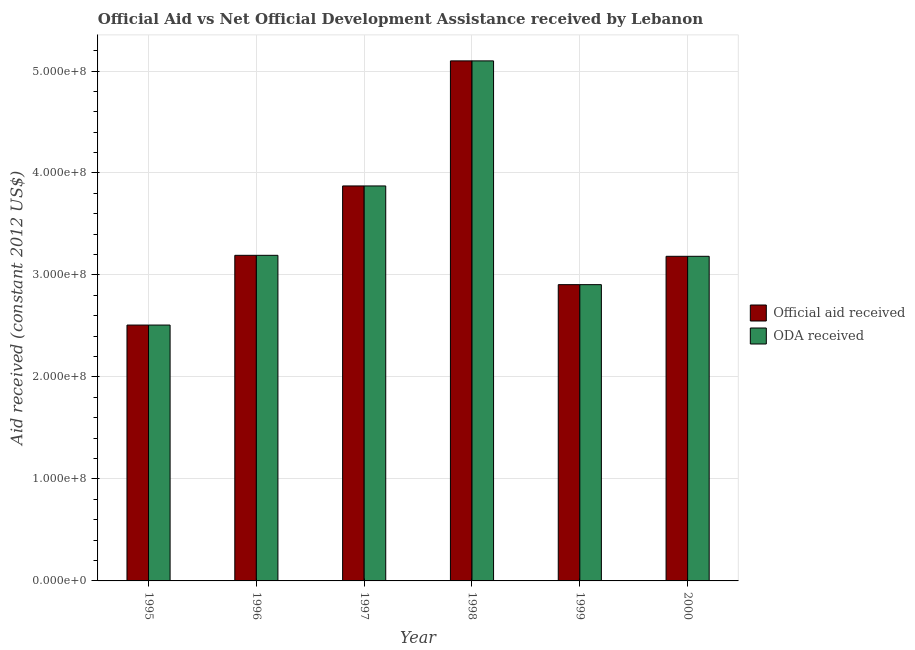How many different coloured bars are there?
Give a very brief answer. 2. Are the number of bars per tick equal to the number of legend labels?
Ensure brevity in your answer.  Yes. Are the number of bars on each tick of the X-axis equal?
Your answer should be compact. Yes. What is the oda received in 1999?
Your answer should be compact. 2.91e+08. Across all years, what is the maximum official aid received?
Your answer should be compact. 5.10e+08. Across all years, what is the minimum oda received?
Ensure brevity in your answer.  2.51e+08. In which year was the oda received minimum?
Provide a succinct answer. 1995. What is the total oda received in the graph?
Keep it short and to the point. 2.08e+09. What is the difference between the official aid received in 1995 and that in 1997?
Make the answer very short. -1.36e+08. What is the difference between the official aid received in 1996 and the oda received in 1997?
Offer a very short reply. -6.80e+07. What is the average oda received per year?
Make the answer very short. 3.46e+08. What is the ratio of the oda received in 1999 to that in 2000?
Make the answer very short. 0.91. What is the difference between the highest and the second highest official aid received?
Give a very brief answer. 1.23e+08. What is the difference between the highest and the lowest oda received?
Offer a very short reply. 2.59e+08. What does the 1st bar from the left in 1999 represents?
Provide a short and direct response. Official aid received. What does the 1st bar from the right in 2000 represents?
Your answer should be compact. ODA received. How many bars are there?
Keep it short and to the point. 12. What is the difference between two consecutive major ticks on the Y-axis?
Your response must be concise. 1.00e+08. Are the values on the major ticks of Y-axis written in scientific E-notation?
Ensure brevity in your answer.  Yes. Does the graph contain grids?
Provide a short and direct response. Yes. How are the legend labels stacked?
Your answer should be very brief. Vertical. What is the title of the graph?
Your answer should be compact. Official Aid vs Net Official Development Assistance received by Lebanon . What is the label or title of the X-axis?
Keep it short and to the point. Year. What is the label or title of the Y-axis?
Keep it short and to the point. Aid received (constant 2012 US$). What is the Aid received (constant 2012 US$) in Official aid received in 1995?
Provide a short and direct response. 2.51e+08. What is the Aid received (constant 2012 US$) of ODA received in 1995?
Your answer should be very brief. 2.51e+08. What is the Aid received (constant 2012 US$) in Official aid received in 1996?
Give a very brief answer. 3.19e+08. What is the Aid received (constant 2012 US$) of ODA received in 1996?
Keep it short and to the point. 3.19e+08. What is the Aid received (constant 2012 US$) of Official aid received in 1997?
Keep it short and to the point. 3.87e+08. What is the Aid received (constant 2012 US$) of ODA received in 1997?
Give a very brief answer. 3.87e+08. What is the Aid received (constant 2012 US$) of Official aid received in 1998?
Provide a succinct answer. 5.10e+08. What is the Aid received (constant 2012 US$) in ODA received in 1998?
Provide a short and direct response. 5.10e+08. What is the Aid received (constant 2012 US$) of Official aid received in 1999?
Your answer should be compact. 2.91e+08. What is the Aid received (constant 2012 US$) in ODA received in 1999?
Offer a very short reply. 2.91e+08. What is the Aid received (constant 2012 US$) in Official aid received in 2000?
Provide a succinct answer. 3.18e+08. What is the Aid received (constant 2012 US$) of ODA received in 2000?
Your answer should be very brief. 3.18e+08. Across all years, what is the maximum Aid received (constant 2012 US$) in Official aid received?
Provide a succinct answer. 5.10e+08. Across all years, what is the maximum Aid received (constant 2012 US$) in ODA received?
Your response must be concise. 5.10e+08. Across all years, what is the minimum Aid received (constant 2012 US$) of Official aid received?
Provide a short and direct response. 2.51e+08. Across all years, what is the minimum Aid received (constant 2012 US$) in ODA received?
Your answer should be compact. 2.51e+08. What is the total Aid received (constant 2012 US$) of Official aid received in the graph?
Provide a short and direct response. 2.08e+09. What is the total Aid received (constant 2012 US$) in ODA received in the graph?
Your answer should be very brief. 2.08e+09. What is the difference between the Aid received (constant 2012 US$) in Official aid received in 1995 and that in 1996?
Provide a succinct answer. -6.84e+07. What is the difference between the Aid received (constant 2012 US$) in ODA received in 1995 and that in 1996?
Ensure brevity in your answer.  -6.84e+07. What is the difference between the Aid received (constant 2012 US$) in Official aid received in 1995 and that in 1997?
Offer a very short reply. -1.36e+08. What is the difference between the Aid received (constant 2012 US$) in ODA received in 1995 and that in 1997?
Your answer should be very brief. -1.36e+08. What is the difference between the Aid received (constant 2012 US$) in Official aid received in 1995 and that in 1998?
Provide a succinct answer. -2.59e+08. What is the difference between the Aid received (constant 2012 US$) of ODA received in 1995 and that in 1998?
Your answer should be compact. -2.59e+08. What is the difference between the Aid received (constant 2012 US$) of Official aid received in 1995 and that in 1999?
Your answer should be very brief. -3.96e+07. What is the difference between the Aid received (constant 2012 US$) in ODA received in 1995 and that in 1999?
Keep it short and to the point. -3.96e+07. What is the difference between the Aid received (constant 2012 US$) in Official aid received in 1995 and that in 2000?
Make the answer very short. -6.74e+07. What is the difference between the Aid received (constant 2012 US$) in ODA received in 1995 and that in 2000?
Your answer should be very brief. -6.74e+07. What is the difference between the Aid received (constant 2012 US$) in Official aid received in 1996 and that in 1997?
Give a very brief answer. -6.80e+07. What is the difference between the Aid received (constant 2012 US$) in ODA received in 1996 and that in 1997?
Provide a short and direct response. -6.80e+07. What is the difference between the Aid received (constant 2012 US$) in Official aid received in 1996 and that in 1998?
Provide a succinct answer. -1.91e+08. What is the difference between the Aid received (constant 2012 US$) in ODA received in 1996 and that in 1998?
Offer a very short reply. -1.91e+08. What is the difference between the Aid received (constant 2012 US$) of Official aid received in 1996 and that in 1999?
Ensure brevity in your answer.  2.88e+07. What is the difference between the Aid received (constant 2012 US$) of ODA received in 1996 and that in 1999?
Ensure brevity in your answer.  2.88e+07. What is the difference between the Aid received (constant 2012 US$) in Official aid received in 1996 and that in 2000?
Your response must be concise. 9.70e+05. What is the difference between the Aid received (constant 2012 US$) in ODA received in 1996 and that in 2000?
Offer a terse response. 9.70e+05. What is the difference between the Aid received (constant 2012 US$) in Official aid received in 1997 and that in 1998?
Your response must be concise. -1.23e+08. What is the difference between the Aid received (constant 2012 US$) in ODA received in 1997 and that in 1998?
Make the answer very short. -1.23e+08. What is the difference between the Aid received (constant 2012 US$) of Official aid received in 1997 and that in 1999?
Ensure brevity in your answer.  9.68e+07. What is the difference between the Aid received (constant 2012 US$) in ODA received in 1997 and that in 1999?
Your answer should be compact. 9.68e+07. What is the difference between the Aid received (constant 2012 US$) of Official aid received in 1997 and that in 2000?
Provide a succinct answer. 6.90e+07. What is the difference between the Aid received (constant 2012 US$) in ODA received in 1997 and that in 2000?
Give a very brief answer. 6.90e+07. What is the difference between the Aid received (constant 2012 US$) of Official aid received in 1998 and that in 1999?
Make the answer very short. 2.19e+08. What is the difference between the Aid received (constant 2012 US$) in ODA received in 1998 and that in 1999?
Your answer should be compact. 2.19e+08. What is the difference between the Aid received (constant 2012 US$) in Official aid received in 1998 and that in 2000?
Keep it short and to the point. 1.92e+08. What is the difference between the Aid received (constant 2012 US$) of ODA received in 1998 and that in 2000?
Keep it short and to the point. 1.92e+08. What is the difference between the Aid received (constant 2012 US$) of Official aid received in 1999 and that in 2000?
Make the answer very short. -2.78e+07. What is the difference between the Aid received (constant 2012 US$) in ODA received in 1999 and that in 2000?
Your response must be concise. -2.78e+07. What is the difference between the Aid received (constant 2012 US$) in Official aid received in 1995 and the Aid received (constant 2012 US$) in ODA received in 1996?
Keep it short and to the point. -6.84e+07. What is the difference between the Aid received (constant 2012 US$) in Official aid received in 1995 and the Aid received (constant 2012 US$) in ODA received in 1997?
Ensure brevity in your answer.  -1.36e+08. What is the difference between the Aid received (constant 2012 US$) of Official aid received in 1995 and the Aid received (constant 2012 US$) of ODA received in 1998?
Give a very brief answer. -2.59e+08. What is the difference between the Aid received (constant 2012 US$) of Official aid received in 1995 and the Aid received (constant 2012 US$) of ODA received in 1999?
Provide a short and direct response. -3.96e+07. What is the difference between the Aid received (constant 2012 US$) of Official aid received in 1995 and the Aid received (constant 2012 US$) of ODA received in 2000?
Ensure brevity in your answer.  -6.74e+07. What is the difference between the Aid received (constant 2012 US$) of Official aid received in 1996 and the Aid received (constant 2012 US$) of ODA received in 1997?
Your answer should be very brief. -6.80e+07. What is the difference between the Aid received (constant 2012 US$) of Official aid received in 1996 and the Aid received (constant 2012 US$) of ODA received in 1998?
Your answer should be very brief. -1.91e+08. What is the difference between the Aid received (constant 2012 US$) in Official aid received in 1996 and the Aid received (constant 2012 US$) in ODA received in 1999?
Provide a short and direct response. 2.88e+07. What is the difference between the Aid received (constant 2012 US$) of Official aid received in 1996 and the Aid received (constant 2012 US$) of ODA received in 2000?
Offer a terse response. 9.70e+05. What is the difference between the Aid received (constant 2012 US$) in Official aid received in 1997 and the Aid received (constant 2012 US$) in ODA received in 1998?
Give a very brief answer. -1.23e+08. What is the difference between the Aid received (constant 2012 US$) of Official aid received in 1997 and the Aid received (constant 2012 US$) of ODA received in 1999?
Ensure brevity in your answer.  9.68e+07. What is the difference between the Aid received (constant 2012 US$) in Official aid received in 1997 and the Aid received (constant 2012 US$) in ODA received in 2000?
Make the answer very short. 6.90e+07. What is the difference between the Aid received (constant 2012 US$) in Official aid received in 1998 and the Aid received (constant 2012 US$) in ODA received in 1999?
Ensure brevity in your answer.  2.19e+08. What is the difference between the Aid received (constant 2012 US$) of Official aid received in 1998 and the Aid received (constant 2012 US$) of ODA received in 2000?
Your answer should be very brief. 1.92e+08. What is the difference between the Aid received (constant 2012 US$) of Official aid received in 1999 and the Aid received (constant 2012 US$) of ODA received in 2000?
Offer a terse response. -2.78e+07. What is the average Aid received (constant 2012 US$) in Official aid received per year?
Ensure brevity in your answer.  3.46e+08. What is the average Aid received (constant 2012 US$) in ODA received per year?
Provide a short and direct response. 3.46e+08. What is the ratio of the Aid received (constant 2012 US$) of Official aid received in 1995 to that in 1996?
Ensure brevity in your answer.  0.79. What is the ratio of the Aid received (constant 2012 US$) in ODA received in 1995 to that in 1996?
Make the answer very short. 0.79. What is the ratio of the Aid received (constant 2012 US$) in Official aid received in 1995 to that in 1997?
Your answer should be very brief. 0.65. What is the ratio of the Aid received (constant 2012 US$) in ODA received in 1995 to that in 1997?
Your answer should be very brief. 0.65. What is the ratio of the Aid received (constant 2012 US$) of Official aid received in 1995 to that in 1998?
Your answer should be very brief. 0.49. What is the ratio of the Aid received (constant 2012 US$) of ODA received in 1995 to that in 1998?
Ensure brevity in your answer.  0.49. What is the ratio of the Aid received (constant 2012 US$) of Official aid received in 1995 to that in 1999?
Give a very brief answer. 0.86. What is the ratio of the Aid received (constant 2012 US$) of ODA received in 1995 to that in 1999?
Provide a short and direct response. 0.86. What is the ratio of the Aid received (constant 2012 US$) of Official aid received in 1995 to that in 2000?
Offer a terse response. 0.79. What is the ratio of the Aid received (constant 2012 US$) of ODA received in 1995 to that in 2000?
Make the answer very short. 0.79. What is the ratio of the Aid received (constant 2012 US$) of Official aid received in 1996 to that in 1997?
Your response must be concise. 0.82. What is the ratio of the Aid received (constant 2012 US$) in ODA received in 1996 to that in 1997?
Your answer should be compact. 0.82. What is the ratio of the Aid received (constant 2012 US$) of Official aid received in 1996 to that in 1998?
Ensure brevity in your answer.  0.63. What is the ratio of the Aid received (constant 2012 US$) in ODA received in 1996 to that in 1998?
Provide a short and direct response. 0.63. What is the ratio of the Aid received (constant 2012 US$) in Official aid received in 1996 to that in 1999?
Provide a succinct answer. 1.1. What is the ratio of the Aid received (constant 2012 US$) of ODA received in 1996 to that in 1999?
Ensure brevity in your answer.  1.1. What is the ratio of the Aid received (constant 2012 US$) in Official aid received in 1996 to that in 2000?
Offer a very short reply. 1. What is the ratio of the Aid received (constant 2012 US$) of Official aid received in 1997 to that in 1998?
Offer a terse response. 0.76. What is the ratio of the Aid received (constant 2012 US$) of ODA received in 1997 to that in 1998?
Your response must be concise. 0.76. What is the ratio of the Aid received (constant 2012 US$) of Official aid received in 1997 to that in 1999?
Keep it short and to the point. 1.33. What is the ratio of the Aid received (constant 2012 US$) of ODA received in 1997 to that in 1999?
Provide a succinct answer. 1.33. What is the ratio of the Aid received (constant 2012 US$) of Official aid received in 1997 to that in 2000?
Offer a very short reply. 1.22. What is the ratio of the Aid received (constant 2012 US$) in ODA received in 1997 to that in 2000?
Offer a terse response. 1.22. What is the ratio of the Aid received (constant 2012 US$) of Official aid received in 1998 to that in 1999?
Your response must be concise. 1.76. What is the ratio of the Aid received (constant 2012 US$) in ODA received in 1998 to that in 1999?
Give a very brief answer. 1.76. What is the ratio of the Aid received (constant 2012 US$) of Official aid received in 1998 to that in 2000?
Ensure brevity in your answer.  1.6. What is the ratio of the Aid received (constant 2012 US$) in ODA received in 1998 to that in 2000?
Your answer should be compact. 1.6. What is the ratio of the Aid received (constant 2012 US$) in Official aid received in 1999 to that in 2000?
Ensure brevity in your answer.  0.91. What is the ratio of the Aid received (constant 2012 US$) in ODA received in 1999 to that in 2000?
Keep it short and to the point. 0.91. What is the difference between the highest and the second highest Aid received (constant 2012 US$) of Official aid received?
Make the answer very short. 1.23e+08. What is the difference between the highest and the second highest Aid received (constant 2012 US$) in ODA received?
Your response must be concise. 1.23e+08. What is the difference between the highest and the lowest Aid received (constant 2012 US$) of Official aid received?
Your answer should be very brief. 2.59e+08. What is the difference between the highest and the lowest Aid received (constant 2012 US$) of ODA received?
Give a very brief answer. 2.59e+08. 